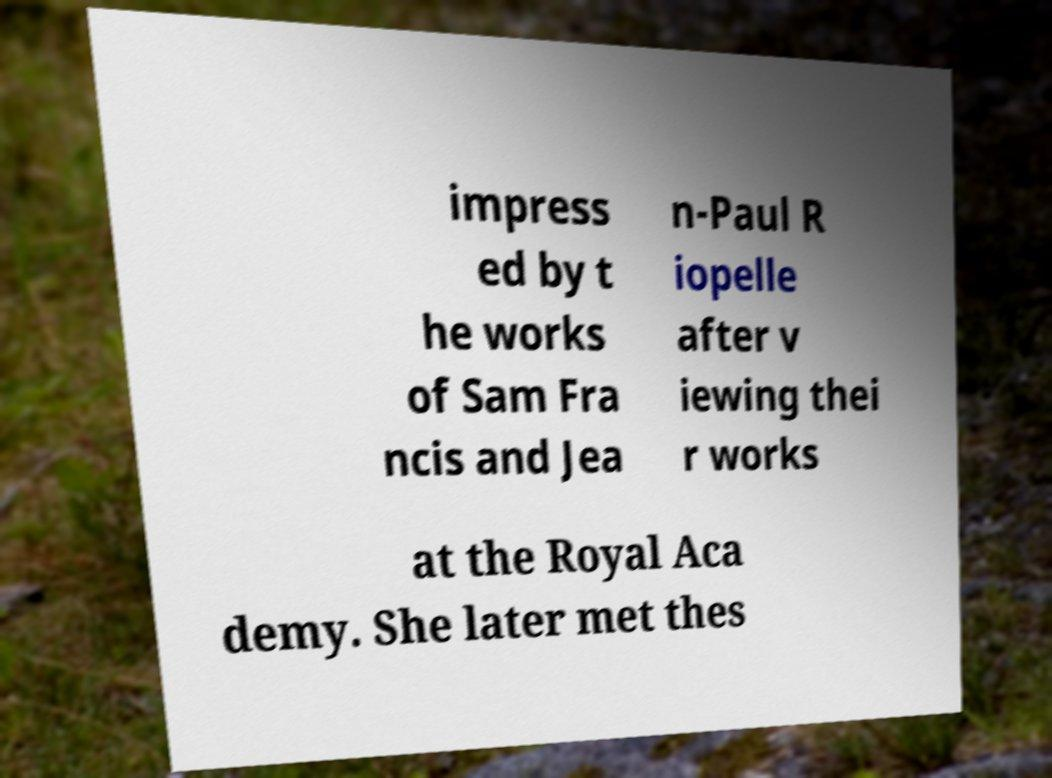There's text embedded in this image that I need extracted. Can you transcribe it verbatim? impress ed by t he works of Sam Fra ncis and Jea n-Paul R iopelle after v iewing thei r works at the Royal Aca demy. She later met thes 